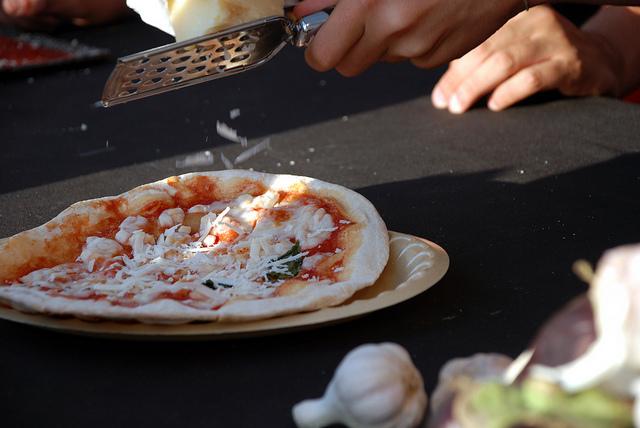What is currently being put onto the pizza?
Answer briefly. Cheese. What is in the foreground of the photo?
Short answer required. Garlic. Is that a deep dish pizza?
Write a very short answer. No. 